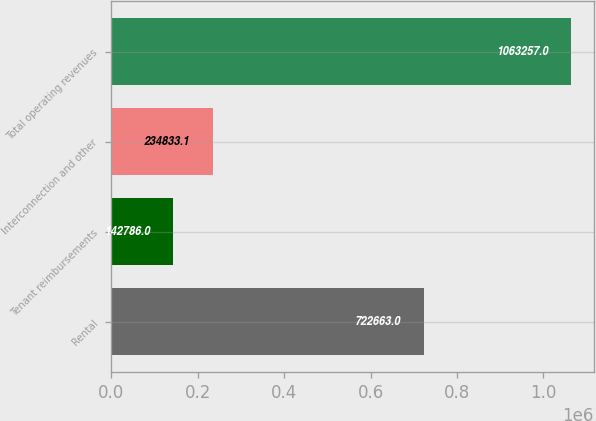Convert chart. <chart><loc_0><loc_0><loc_500><loc_500><bar_chart><fcel>Rental<fcel>Tenant reimbursements<fcel>Interconnection and other<fcel>Total operating revenues<nl><fcel>722663<fcel>142786<fcel>234833<fcel>1.06326e+06<nl></chart> 